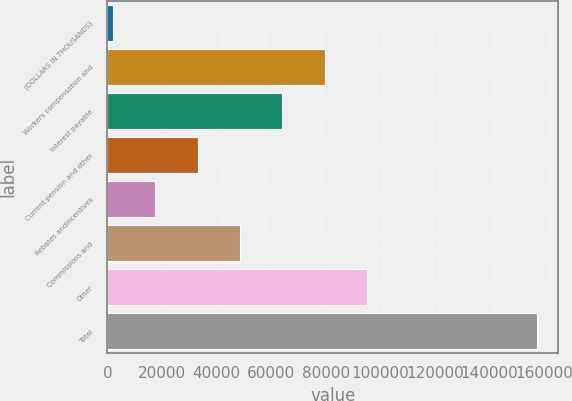<chart> <loc_0><loc_0><loc_500><loc_500><bar_chart><fcel>(DOLLARS IN THOUSANDS)<fcel>Workers compensation and<fcel>Interest payable<fcel>Current pension and other<fcel>Rebates andincentives<fcel>Commissions and<fcel>Other<fcel>Total<nl><fcel>2008<fcel>79669.5<fcel>64137.2<fcel>33072.6<fcel>17540.3<fcel>48604.9<fcel>95201.8<fcel>157331<nl></chart> 